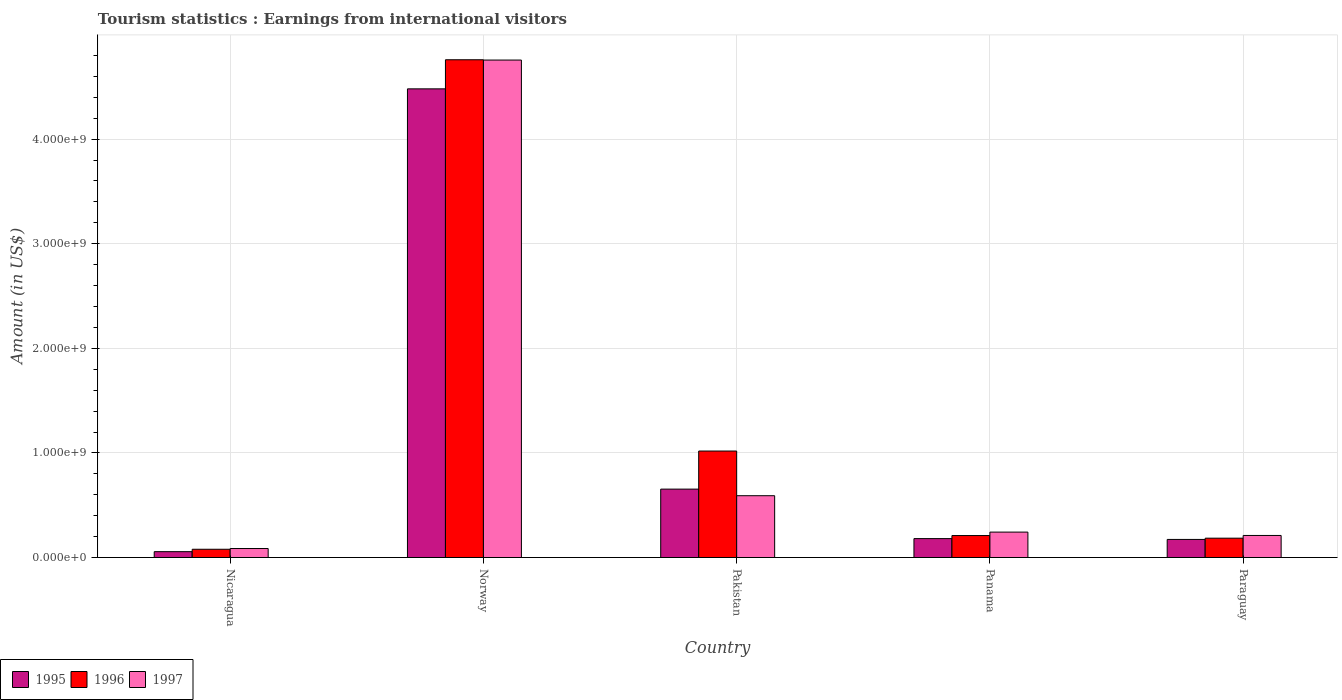How many groups of bars are there?
Provide a short and direct response. 5. How many bars are there on the 2nd tick from the left?
Your answer should be very brief. 3. What is the label of the 5th group of bars from the left?
Keep it short and to the point. Paraguay. What is the earnings from international visitors in 1997 in Pakistan?
Give a very brief answer. 5.91e+08. Across all countries, what is the maximum earnings from international visitors in 1997?
Your answer should be very brief. 4.76e+09. Across all countries, what is the minimum earnings from international visitors in 1995?
Ensure brevity in your answer.  5.60e+07. In which country was the earnings from international visitors in 1995 minimum?
Keep it short and to the point. Nicaragua. What is the total earnings from international visitors in 1997 in the graph?
Your answer should be very brief. 5.89e+09. What is the difference between the earnings from international visitors in 1997 in Nicaragua and that in Norway?
Keep it short and to the point. -4.67e+09. What is the difference between the earnings from international visitors in 1995 in Paraguay and the earnings from international visitors in 1997 in Pakistan?
Offer a terse response. -4.18e+08. What is the average earnings from international visitors in 1995 per country?
Offer a very short reply. 1.11e+09. What is the difference between the earnings from international visitors of/in 1997 and earnings from international visitors of/in 1995 in Pakistan?
Provide a succinct answer. -6.30e+07. In how many countries, is the earnings from international visitors in 1996 greater than 1400000000 US$?
Make the answer very short. 1. What is the ratio of the earnings from international visitors in 1997 in Nicaragua to that in Paraguay?
Keep it short and to the point. 0.41. What is the difference between the highest and the second highest earnings from international visitors in 1996?
Your response must be concise. 4.55e+09. What is the difference between the highest and the lowest earnings from international visitors in 1996?
Give a very brief answer. 4.68e+09. In how many countries, is the earnings from international visitors in 1995 greater than the average earnings from international visitors in 1995 taken over all countries?
Your answer should be very brief. 1. Is the sum of the earnings from international visitors in 1996 in Nicaragua and Paraguay greater than the maximum earnings from international visitors in 1997 across all countries?
Your answer should be very brief. No. What does the 1st bar from the left in Pakistan represents?
Make the answer very short. 1995. Are all the bars in the graph horizontal?
Offer a terse response. No. What is the difference between two consecutive major ticks on the Y-axis?
Offer a terse response. 1.00e+09. Does the graph contain grids?
Make the answer very short. Yes. How many legend labels are there?
Give a very brief answer. 3. How are the legend labels stacked?
Offer a very short reply. Horizontal. What is the title of the graph?
Ensure brevity in your answer.  Tourism statistics : Earnings from international visitors. Does "1962" appear as one of the legend labels in the graph?
Give a very brief answer. No. What is the label or title of the X-axis?
Ensure brevity in your answer.  Country. What is the label or title of the Y-axis?
Keep it short and to the point. Amount (in US$). What is the Amount (in US$) in 1995 in Nicaragua?
Keep it short and to the point. 5.60e+07. What is the Amount (in US$) of 1996 in Nicaragua?
Ensure brevity in your answer.  7.90e+07. What is the Amount (in US$) of 1997 in Nicaragua?
Give a very brief answer. 8.60e+07. What is the Amount (in US$) in 1995 in Norway?
Offer a very short reply. 4.48e+09. What is the Amount (in US$) of 1996 in Norway?
Ensure brevity in your answer.  4.76e+09. What is the Amount (in US$) in 1997 in Norway?
Give a very brief answer. 4.76e+09. What is the Amount (in US$) in 1995 in Pakistan?
Ensure brevity in your answer.  6.54e+08. What is the Amount (in US$) in 1996 in Pakistan?
Give a very brief answer. 1.02e+09. What is the Amount (in US$) of 1997 in Pakistan?
Offer a terse response. 5.91e+08. What is the Amount (in US$) in 1995 in Panama?
Offer a terse response. 1.81e+08. What is the Amount (in US$) of 1996 in Panama?
Your response must be concise. 2.10e+08. What is the Amount (in US$) in 1997 in Panama?
Your answer should be very brief. 2.43e+08. What is the Amount (in US$) in 1995 in Paraguay?
Your answer should be compact. 1.73e+08. What is the Amount (in US$) in 1996 in Paraguay?
Provide a short and direct response. 1.85e+08. What is the Amount (in US$) in 1997 in Paraguay?
Your answer should be very brief. 2.11e+08. Across all countries, what is the maximum Amount (in US$) in 1995?
Your answer should be very brief. 4.48e+09. Across all countries, what is the maximum Amount (in US$) in 1996?
Offer a terse response. 4.76e+09. Across all countries, what is the maximum Amount (in US$) of 1997?
Ensure brevity in your answer.  4.76e+09. Across all countries, what is the minimum Amount (in US$) in 1995?
Provide a succinct answer. 5.60e+07. Across all countries, what is the minimum Amount (in US$) in 1996?
Offer a terse response. 7.90e+07. Across all countries, what is the minimum Amount (in US$) of 1997?
Your response must be concise. 8.60e+07. What is the total Amount (in US$) in 1995 in the graph?
Offer a terse response. 5.54e+09. What is the total Amount (in US$) in 1996 in the graph?
Give a very brief answer. 6.25e+09. What is the total Amount (in US$) in 1997 in the graph?
Give a very brief answer. 5.89e+09. What is the difference between the Amount (in US$) in 1995 in Nicaragua and that in Norway?
Ensure brevity in your answer.  -4.42e+09. What is the difference between the Amount (in US$) of 1996 in Nicaragua and that in Norway?
Your answer should be very brief. -4.68e+09. What is the difference between the Amount (in US$) of 1997 in Nicaragua and that in Norway?
Give a very brief answer. -4.67e+09. What is the difference between the Amount (in US$) of 1995 in Nicaragua and that in Pakistan?
Offer a terse response. -5.98e+08. What is the difference between the Amount (in US$) of 1996 in Nicaragua and that in Pakistan?
Your answer should be very brief. -9.39e+08. What is the difference between the Amount (in US$) in 1997 in Nicaragua and that in Pakistan?
Offer a terse response. -5.05e+08. What is the difference between the Amount (in US$) in 1995 in Nicaragua and that in Panama?
Keep it short and to the point. -1.25e+08. What is the difference between the Amount (in US$) of 1996 in Nicaragua and that in Panama?
Your answer should be very brief. -1.31e+08. What is the difference between the Amount (in US$) in 1997 in Nicaragua and that in Panama?
Offer a terse response. -1.57e+08. What is the difference between the Amount (in US$) of 1995 in Nicaragua and that in Paraguay?
Keep it short and to the point. -1.17e+08. What is the difference between the Amount (in US$) in 1996 in Nicaragua and that in Paraguay?
Your answer should be very brief. -1.06e+08. What is the difference between the Amount (in US$) of 1997 in Nicaragua and that in Paraguay?
Your answer should be very brief. -1.25e+08. What is the difference between the Amount (in US$) of 1995 in Norway and that in Pakistan?
Your response must be concise. 3.83e+09. What is the difference between the Amount (in US$) of 1996 in Norway and that in Pakistan?
Offer a terse response. 3.74e+09. What is the difference between the Amount (in US$) in 1997 in Norway and that in Pakistan?
Provide a short and direct response. 4.16e+09. What is the difference between the Amount (in US$) in 1995 in Norway and that in Panama?
Offer a very short reply. 4.30e+09. What is the difference between the Amount (in US$) in 1996 in Norway and that in Panama?
Your response must be concise. 4.55e+09. What is the difference between the Amount (in US$) in 1997 in Norway and that in Panama?
Ensure brevity in your answer.  4.51e+09. What is the difference between the Amount (in US$) in 1995 in Norway and that in Paraguay?
Keep it short and to the point. 4.31e+09. What is the difference between the Amount (in US$) in 1996 in Norway and that in Paraguay?
Make the answer very short. 4.57e+09. What is the difference between the Amount (in US$) of 1997 in Norway and that in Paraguay?
Ensure brevity in your answer.  4.54e+09. What is the difference between the Amount (in US$) of 1995 in Pakistan and that in Panama?
Provide a succinct answer. 4.73e+08. What is the difference between the Amount (in US$) in 1996 in Pakistan and that in Panama?
Offer a very short reply. 8.08e+08. What is the difference between the Amount (in US$) of 1997 in Pakistan and that in Panama?
Your answer should be compact. 3.48e+08. What is the difference between the Amount (in US$) in 1995 in Pakistan and that in Paraguay?
Give a very brief answer. 4.81e+08. What is the difference between the Amount (in US$) in 1996 in Pakistan and that in Paraguay?
Offer a terse response. 8.33e+08. What is the difference between the Amount (in US$) in 1997 in Pakistan and that in Paraguay?
Ensure brevity in your answer.  3.80e+08. What is the difference between the Amount (in US$) of 1996 in Panama and that in Paraguay?
Ensure brevity in your answer.  2.50e+07. What is the difference between the Amount (in US$) of 1997 in Panama and that in Paraguay?
Offer a very short reply. 3.20e+07. What is the difference between the Amount (in US$) of 1995 in Nicaragua and the Amount (in US$) of 1996 in Norway?
Provide a succinct answer. -4.70e+09. What is the difference between the Amount (in US$) of 1995 in Nicaragua and the Amount (in US$) of 1997 in Norway?
Your answer should be compact. -4.70e+09. What is the difference between the Amount (in US$) in 1996 in Nicaragua and the Amount (in US$) in 1997 in Norway?
Provide a short and direct response. -4.68e+09. What is the difference between the Amount (in US$) in 1995 in Nicaragua and the Amount (in US$) in 1996 in Pakistan?
Give a very brief answer. -9.62e+08. What is the difference between the Amount (in US$) in 1995 in Nicaragua and the Amount (in US$) in 1997 in Pakistan?
Ensure brevity in your answer.  -5.35e+08. What is the difference between the Amount (in US$) of 1996 in Nicaragua and the Amount (in US$) of 1997 in Pakistan?
Provide a succinct answer. -5.12e+08. What is the difference between the Amount (in US$) of 1995 in Nicaragua and the Amount (in US$) of 1996 in Panama?
Offer a very short reply. -1.54e+08. What is the difference between the Amount (in US$) in 1995 in Nicaragua and the Amount (in US$) in 1997 in Panama?
Give a very brief answer. -1.87e+08. What is the difference between the Amount (in US$) in 1996 in Nicaragua and the Amount (in US$) in 1997 in Panama?
Offer a terse response. -1.64e+08. What is the difference between the Amount (in US$) of 1995 in Nicaragua and the Amount (in US$) of 1996 in Paraguay?
Provide a short and direct response. -1.29e+08. What is the difference between the Amount (in US$) of 1995 in Nicaragua and the Amount (in US$) of 1997 in Paraguay?
Offer a terse response. -1.55e+08. What is the difference between the Amount (in US$) in 1996 in Nicaragua and the Amount (in US$) in 1997 in Paraguay?
Offer a very short reply. -1.32e+08. What is the difference between the Amount (in US$) of 1995 in Norway and the Amount (in US$) of 1996 in Pakistan?
Give a very brief answer. 3.46e+09. What is the difference between the Amount (in US$) in 1995 in Norway and the Amount (in US$) in 1997 in Pakistan?
Ensure brevity in your answer.  3.89e+09. What is the difference between the Amount (in US$) of 1996 in Norway and the Amount (in US$) of 1997 in Pakistan?
Your answer should be very brief. 4.17e+09. What is the difference between the Amount (in US$) in 1995 in Norway and the Amount (in US$) in 1996 in Panama?
Offer a very short reply. 4.27e+09. What is the difference between the Amount (in US$) of 1995 in Norway and the Amount (in US$) of 1997 in Panama?
Offer a very short reply. 4.24e+09. What is the difference between the Amount (in US$) of 1996 in Norway and the Amount (in US$) of 1997 in Panama?
Provide a short and direct response. 4.52e+09. What is the difference between the Amount (in US$) in 1995 in Norway and the Amount (in US$) in 1996 in Paraguay?
Provide a short and direct response. 4.30e+09. What is the difference between the Amount (in US$) in 1995 in Norway and the Amount (in US$) in 1997 in Paraguay?
Make the answer very short. 4.27e+09. What is the difference between the Amount (in US$) in 1996 in Norway and the Amount (in US$) in 1997 in Paraguay?
Ensure brevity in your answer.  4.55e+09. What is the difference between the Amount (in US$) of 1995 in Pakistan and the Amount (in US$) of 1996 in Panama?
Provide a succinct answer. 4.44e+08. What is the difference between the Amount (in US$) of 1995 in Pakistan and the Amount (in US$) of 1997 in Panama?
Offer a very short reply. 4.11e+08. What is the difference between the Amount (in US$) in 1996 in Pakistan and the Amount (in US$) in 1997 in Panama?
Your answer should be compact. 7.75e+08. What is the difference between the Amount (in US$) of 1995 in Pakistan and the Amount (in US$) of 1996 in Paraguay?
Offer a very short reply. 4.69e+08. What is the difference between the Amount (in US$) of 1995 in Pakistan and the Amount (in US$) of 1997 in Paraguay?
Your response must be concise. 4.43e+08. What is the difference between the Amount (in US$) of 1996 in Pakistan and the Amount (in US$) of 1997 in Paraguay?
Make the answer very short. 8.07e+08. What is the difference between the Amount (in US$) in 1995 in Panama and the Amount (in US$) in 1997 in Paraguay?
Ensure brevity in your answer.  -3.00e+07. What is the difference between the Amount (in US$) in 1996 in Panama and the Amount (in US$) in 1997 in Paraguay?
Offer a very short reply. -1.00e+06. What is the average Amount (in US$) in 1995 per country?
Ensure brevity in your answer.  1.11e+09. What is the average Amount (in US$) in 1996 per country?
Make the answer very short. 1.25e+09. What is the average Amount (in US$) in 1997 per country?
Keep it short and to the point. 1.18e+09. What is the difference between the Amount (in US$) of 1995 and Amount (in US$) of 1996 in Nicaragua?
Your answer should be compact. -2.30e+07. What is the difference between the Amount (in US$) in 1995 and Amount (in US$) in 1997 in Nicaragua?
Offer a very short reply. -3.00e+07. What is the difference between the Amount (in US$) in 1996 and Amount (in US$) in 1997 in Nicaragua?
Your answer should be compact. -7.00e+06. What is the difference between the Amount (in US$) in 1995 and Amount (in US$) in 1996 in Norway?
Ensure brevity in your answer.  -2.78e+08. What is the difference between the Amount (in US$) in 1995 and Amount (in US$) in 1997 in Norway?
Offer a terse response. -2.75e+08. What is the difference between the Amount (in US$) in 1996 and Amount (in US$) in 1997 in Norway?
Your answer should be compact. 2.85e+06. What is the difference between the Amount (in US$) of 1995 and Amount (in US$) of 1996 in Pakistan?
Provide a short and direct response. -3.64e+08. What is the difference between the Amount (in US$) of 1995 and Amount (in US$) of 1997 in Pakistan?
Offer a terse response. 6.30e+07. What is the difference between the Amount (in US$) in 1996 and Amount (in US$) in 1997 in Pakistan?
Keep it short and to the point. 4.27e+08. What is the difference between the Amount (in US$) of 1995 and Amount (in US$) of 1996 in Panama?
Provide a succinct answer. -2.90e+07. What is the difference between the Amount (in US$) of 1995 and Amount (in US$) of 1997 in Panama?
Keep it short and to the point. -6.20e+07. What is the difference between the Amount (in US$) of 1996 and Amount (in US$) of 1997 in Panama?
Keep it short and to the point. -3.30e+07. What is the difference between the Amount (in US$) in 1995 and Amount (in US$) in 1996 in Paraguay?
Your response must be concise. -1.20e+07. What is the difference between the Amount (in US$) in 1995 and Amount (in US$) in 1997 in Paraguay?
Your response must be concise. -3.80e+07. What is the difference between the Amount (in US$) in 1996 and Amount (in US$) in 1997 in Paraguay?
Keep it short and to the point. -2.60e+07. What is the ratio of the Amount (in US$) of 1995 in Nicaragua to that in Norway?
Offer a very short reply. 0.01. What is the ratio of the Amount (in US$) of 1996 in Nicaragua to that in Norway?
Your response must be concise. 0.02. What is the ratio of the Amount (in US$) of 1997 in Nicaragua to that in Norway?
Your response must be concise. 0.02. What is the ratio of the Amount (in US$) of 1995 in Nicaragua to that in Pakistan?
Your answer should be compact. 0.09. What is the ratio of the Amount (in US$) of 1996 in Nicaragua to that in Pakistan?
Provide a short and direct response. 0.08. What is the ratio of the Amount (in US$) in 1997 in Nicaragua to that in Pakistan?
Your answer should be very brief. 0.15. What is the ratio of the Amount (in US$) in 1995 in Nicaragua to that in Panama?
Make the answer very short. 0.31. What is the ratio of the Amount (in US$) in 1996 in Nicaragua to that in Panama?
Keep it short and to the point. 0.38. What is the ratio of the Amount (in US$) of 1997 in Nicaragua to that in Panama?
Keep it short and to the point. 0.35. What is the ratio of the Amount (in US$) of 1995 in Nicaragua to that in Paraguay?
Your answer should be compact. 0.32. What is the ratio of the Amount (in US$) in 1996 in Nicaragua to that in Paraguay?
Ensure brevity in your answer.  0.43. What is the ratio of the Amount (in US$) of 1997 in Nicaragua to that in Paraguay?
Make the answer very short. 0.41. What is the ratio of the Amount (in US$) of 1995 in Norway to that in Pakistan?
Offer a terse response. 6.85. What is the ratio of the Amount (in US$) of 1996 in Norway to that in Pakistan?
Your answer should be compact. 4.67. What is the ratio of the Amount (in US$) of 1997 in Norway to that in Pakistan?
Your answer should be compact. 8.05. What is the ratio of the Amount (in US$) of 1995 in Norway to that in Panama?
Offer a very short reply. 24.76. What is the ratio of the Amount (in US$) of 1996 in Norway to that in Panama?
Make the answer very short. 22.66. What is the ratio of the Amount (in US$) of 1997 in Norway to that in Panama?
Your response must be concise. 19.57. What is the ratio of the Amount (in US$) of 1995 in Norway to that in Paraguay?
Offer a very short reply. 25.9. What is the ratio of the Amount (in US$) in 1996 in Norway to that in Paraguay?
Offer a very short reply. 25.72. What is the ratio of the Amount (in US$) in 1997 in Norway to that in Paraguay?
Keep it short and to the point. 22.54. What is the ratio of the Amount (in US$) of 1995 in Pakistan to that in Panama?
Offer a very short reply. 3.61. What is the ratio of the Amount (in US$) in 1996 in Pakistan to that in Panama?
Give a very brief answer. 4.85. What is the ratio of the Amount (in US$) in 1997 in Pakistan to that in Panama?
Provide a succinct answer. 2.43. What is the ratio of the Amount (in US$) of 1995 in Pakistan to that in Paraguay?
Make the answer very short. 3.78. What is the ratio of the Amount (in US$) of 1996 in Pakistan to that in Paraguay?
Make the answer very short. 5.5. What is the ratio of the Amount (in US$) in 1997 in Pakistan to that in Paraguay?
Your answer should be very brief. 2.8. What is the ratio of the Amount (in US$) of 1995 in Panama to that in Paraguay?
Ensure brevity in your answer.  1.05. What is the ratio of the Amount (in US$) of 1996 in Panama to that in Paraguay?
Your response must be concise. 1.14. What is the ratio of the Amount (in US$) in 1997 in Panama to that in Paraguay?
Your response must be concise. 1.15. What is the difference between the highest and the second highest Amount (in US$) in 1995?
Your answer should be very brief. 3.83e+09. What is the difference between the highest and the second highest Amount (in US$) in 1996?
Your response must be concise. 3.74e+09. What is the difference between the highest and the second highest Amount (in US$) in 1997?
Keep it short and to the point. 4.16e+09. What is the difference between the highest and the lowest Amount (in US$) of 1995?
Your answer should be very brief. 4.42e+09. What is the difference between the highest and the lowest Amount (in US$) in 1996?
Keep it short and to the point. 4.68e+09. What is the difference between the highest and the lowest Amount (in US$) of 1997?
Offer a terse response. 4.67e+09. 